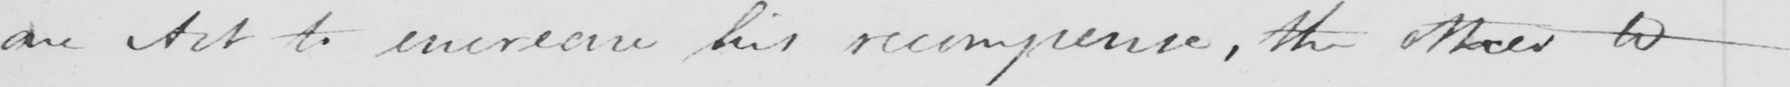Can you read and transcribe this handwriting? an Act to increase his recompense , the other to 